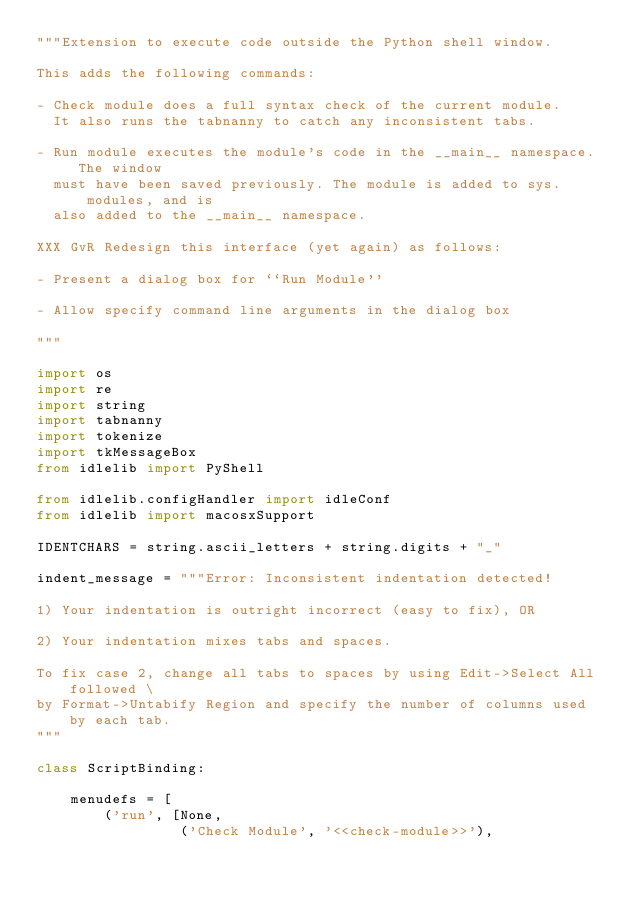Convert code to text. <code><loc_0><loc_0><loc_500><loc_500><_Python_>"""Extension to execute code outside the Python shell window.

This adds the following commands:

- Check module does a full syntax check of the current module.
  It also runs the tabnanny to catch any inconsistent tabs.

- Run module executes the module's code in the __main__ namespace.  The window
  must have been saved previously. The module is added to sys.modules, and is
  also added to the __main__ namespace.

XXX GvR Redesign this interface (yet again) as follows:

- Present a dialog box for ``Run Module''

- Allow specify command line arguments in the dialog box

"""

import os
import re
import string
import tabnanny
import tokenize
import tkMessageBox
from idlelib import PyShell

from idlelib.configHandler import idleConf
from idlelib import macosxSupport

IDENTCHARS = string.ascii_letters + string.digits + "_"

indent_message = """Error: Inconsistent indentation detected!

1) Your indentation is outright incorrect (easy to fix), OR

2) Your indentation mixes tabs and spaces.

To fix case 2, change all tabs to spaces by using Edit->Select All followed \
by Format->Untabify Region and specify the number of columns used by each tab.
"""

class ScriptBinding:

    menudefs = [
        ('run', [None,
                 ('Check Module', '<<check-module>>'),</code> 